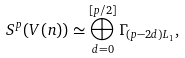<formula> <loc_0><loc_0><loc_500><loc_500>S ^ { p } ( V ( n ) ) \simeq \bigoplus _ { d = 0 } ^ { [ p / 2 ] } \Gamma _ { ( p - 2 d ) L _ { 1 } } ,</formula> 